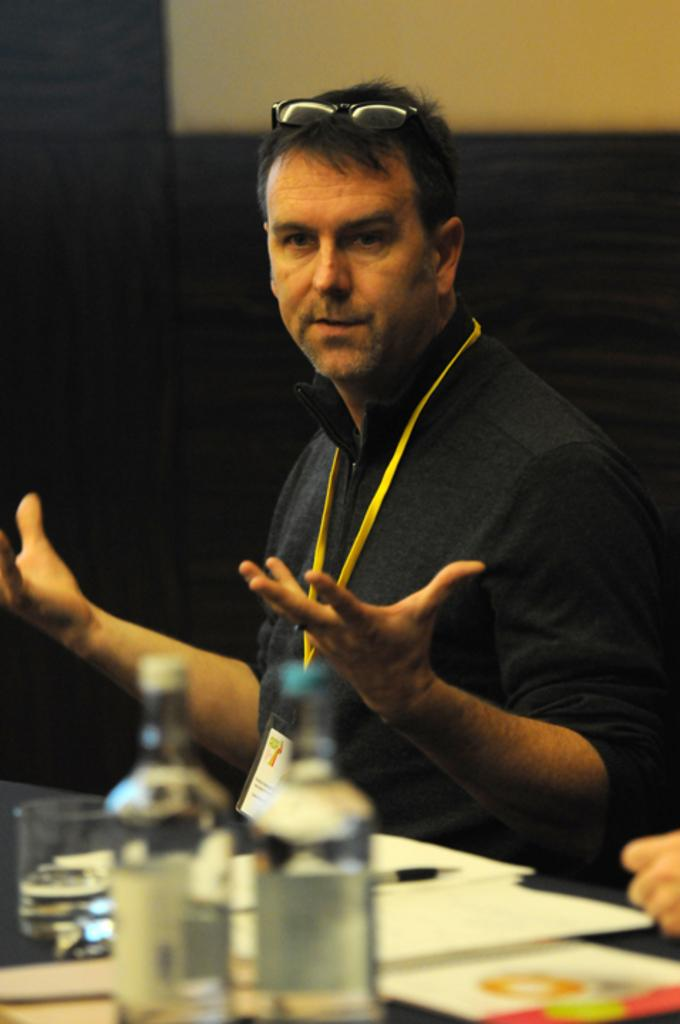What is the person in the image doing? The person is sitting near the table. What objects are on the table in the image? There are bottles, a glass, papers, and a pen on the table. What is the background of the image? There is a wall in the background of the image. What type of rabbit can be seen hopping on the table in the image? There is no rabbit present on the table in the image. What is the person selecting from the papers on the table in the image? The provided facts do not mention any selection process or specific items on the papers, so we cannot determine what the person is selecting. 